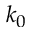Convert formula to latex. <formula><loc_0><loc_0><loc_500><loc_500>k _ { 0 }</formula> 